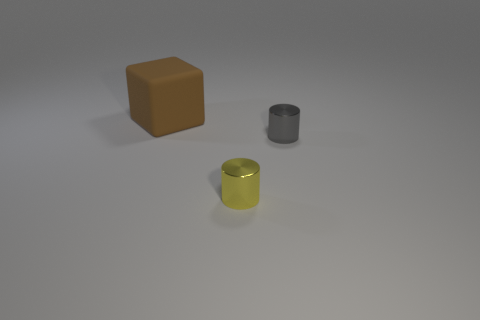Add 2 yellow shiny cylinders. How many objects exist? 5 Subtract all cylinders. How many objects are left? 1 Add 1 small gray metallic objects. How many small gray metallic objects are left? 2 Add 2 metallic objects. How many metallic objects exist? 4 Subtract 0 red cylinders. How many objects are left? 3 Subtract all large brown matte cubes. Subtract all small yellow objects. How many objects are left? 1 